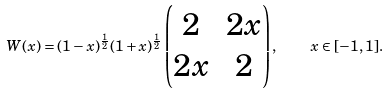<formula> <loc_0><loc_0><loc_500><loc_500>W ( x ) = ( 1 - x ) ^ { \frac { 1 } { 2 } } ( 1 + x ) ^ { \frac { 1 } { 2 } } \begin{pmatrix} 2 & 2 x \\ 2 x & 2 \end{pmatrix} , \quad x \in [ - 1 , 1 ] .</formula> 